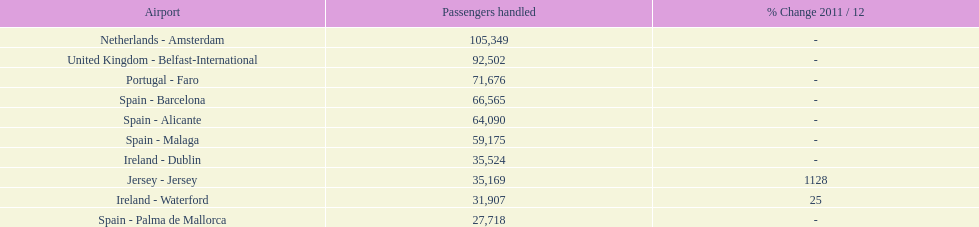How many passengers are going to or coming from spain? 217,548. 